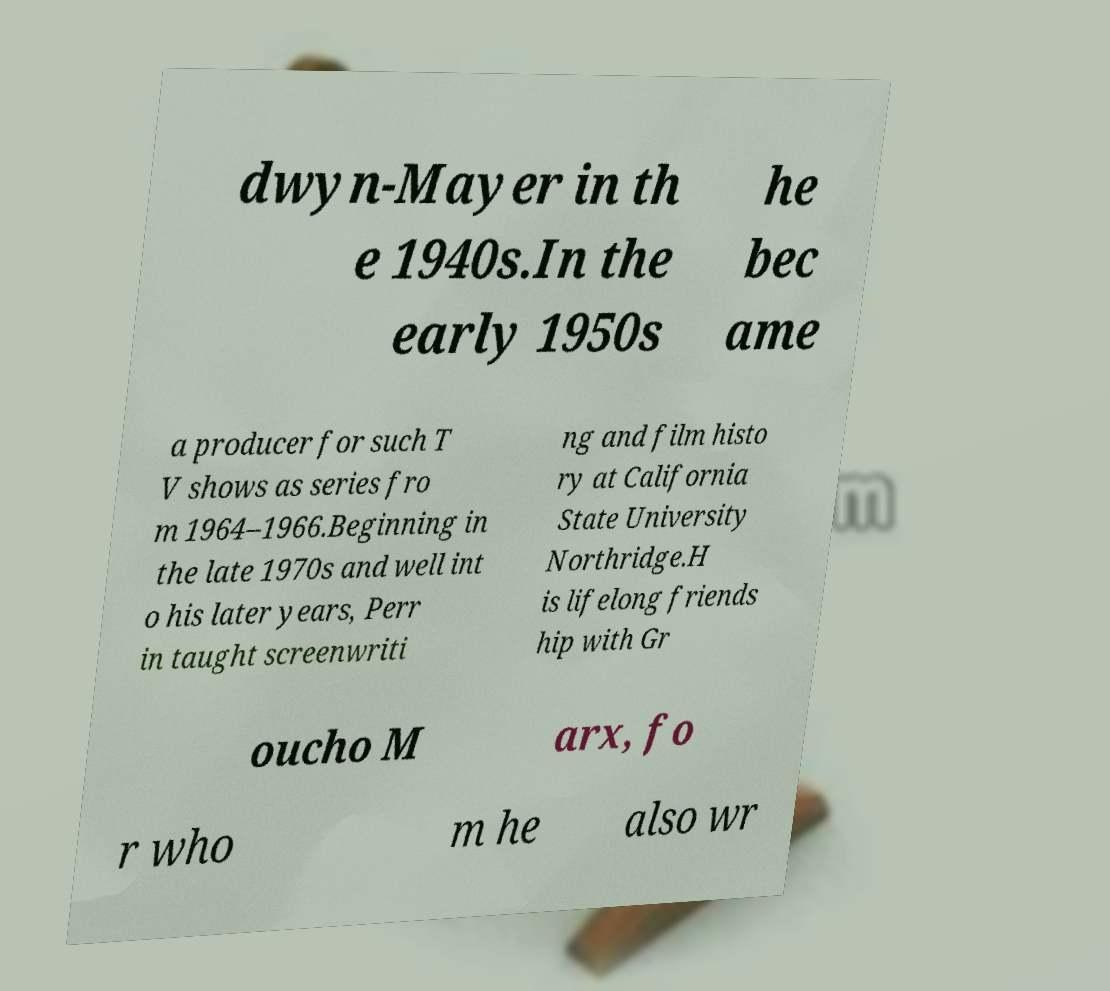Could you extract and type out the text from this image? dwyn-Mayer in th e 1940s.In the early 1950s he bec ame a producer for such T V shows as series fro m 1964–1966.Beginning in the late 1970s and well int o his later years, Perr in taught screenwriti ng and film histo ry at California State University Northridge.H is lifelong friends hip with Gr oucho M arx, fo r who m he also wr 